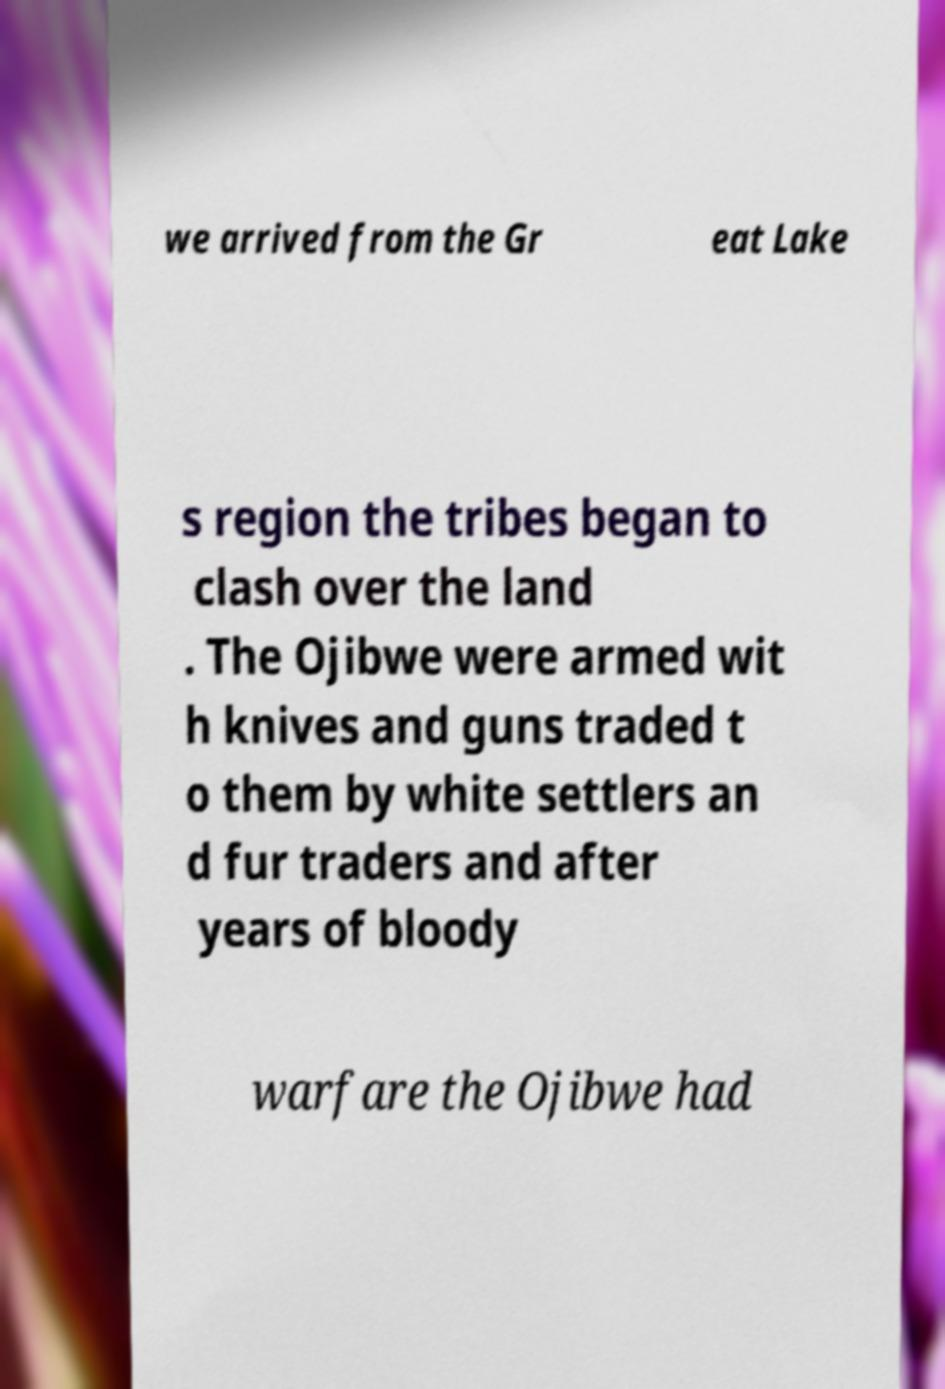Could you extract and type out the text from this image? we arrived from the Gr eat Lake s region the tribes began to clash over the land . The Ojibwe were armed wit h knives and guns traded t o them by white settlers an d fur traders and after years of bloody warfare the Ojibwe had 